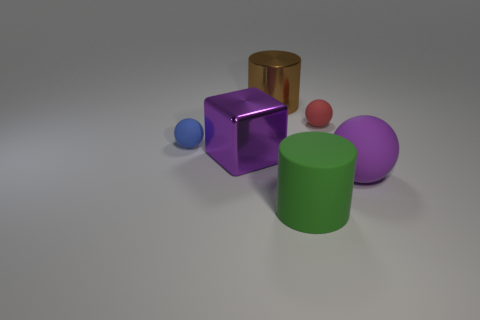Add 2 big purple rubber objects. How many objects exist? 8 Subtract all blocks. How many objects are left? 5 Add 2 blue balls. How many blue balls exist? 3 Subtract 0 cyan spheres. How many objects are left? 6 Subtract all purple objects. Subtract all large yellow matte cylinders. How many objects are left? 4 Add 5 blue matte objects. How many blue matte objects are left? 6 